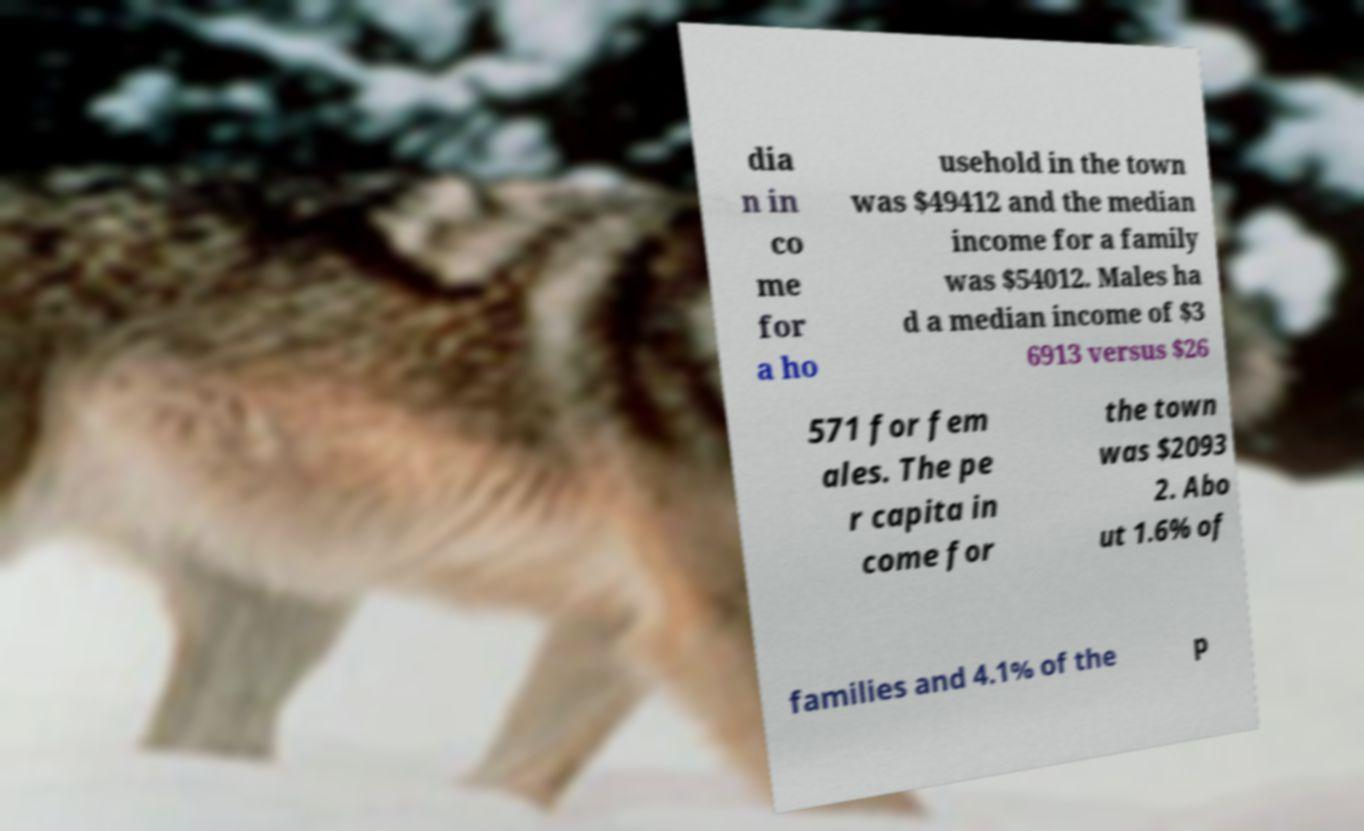What messages or text are displayed in this image? I need them in a readable, typed format. dia n in co me for a ho usehold in the town was $49412 and the median income for a family was $54012. Males ha d a median income of $3 6913 versus $26 571 for fem ales. The pe r capita in come for the town was $2093 2. Abo ut 1.6% of families and 4.1% of the p 